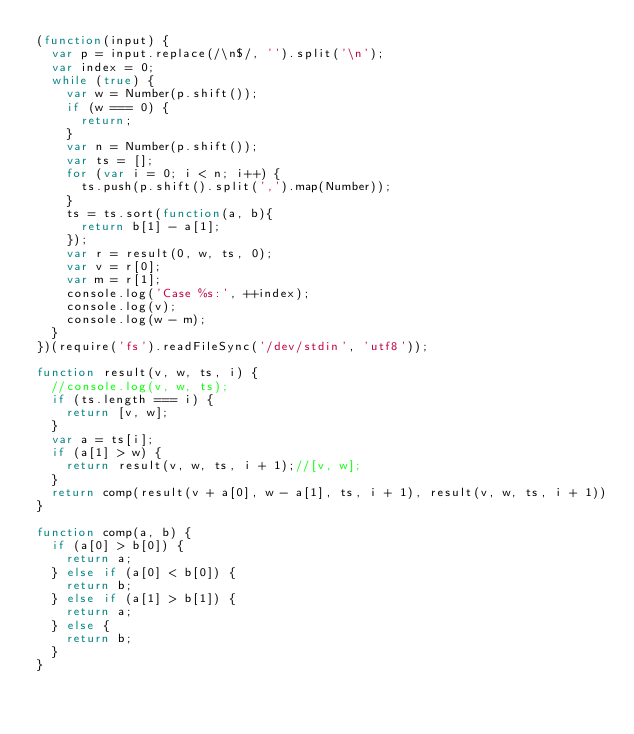<code> <loc_0><loc_0><loc_500><loc_500><_JavaScript_>(function(input) {
  var p = input.replace(/\n$/, '').split('\n');
  var index = 0;
  while (true) {
    var w = Number(p.shift());
    if (w === 0) {
      return;
    }
    var n = Number(p.shift());
    var ts = [];
    for (var i = 0; i < n; i++) {
      ts.push(p.shift().split(',').map(Number));
    }
    ts = ts.sort(function(a, b){
      return b[1] - a[1];
    });
    var r = result(0, w, ts, 0);
    var v = r[0];
    var m = r[1];
    console.log('Case %s:', ++index);
    console.log(v);
    console.log(w - m);
  }
})(require('fs').readFileSync('/dev/stdin', 'utf8'));

function result(v, w, ts, i) {
  //console.log(v, w, ts);
  if (ts.length === i) {
    return [v, w];
  }
  var a = ts[i];
  if (a[1] > w) {
    return result(v, w, ts, i + 1);//[v, w];
  }
  return comp(result(v + a[0], w - a[1], ts, i + 1), result(v, w, ts, i + 1))
}

function comp(a, b) {
  if (a[0] > b[0]) {
    return a;
  } else if (a[0] < b[0]) {
    return b;
  } else if (a[1] > b[1]) {
    return a;
  } else {
    return b;
  }
}</code> 